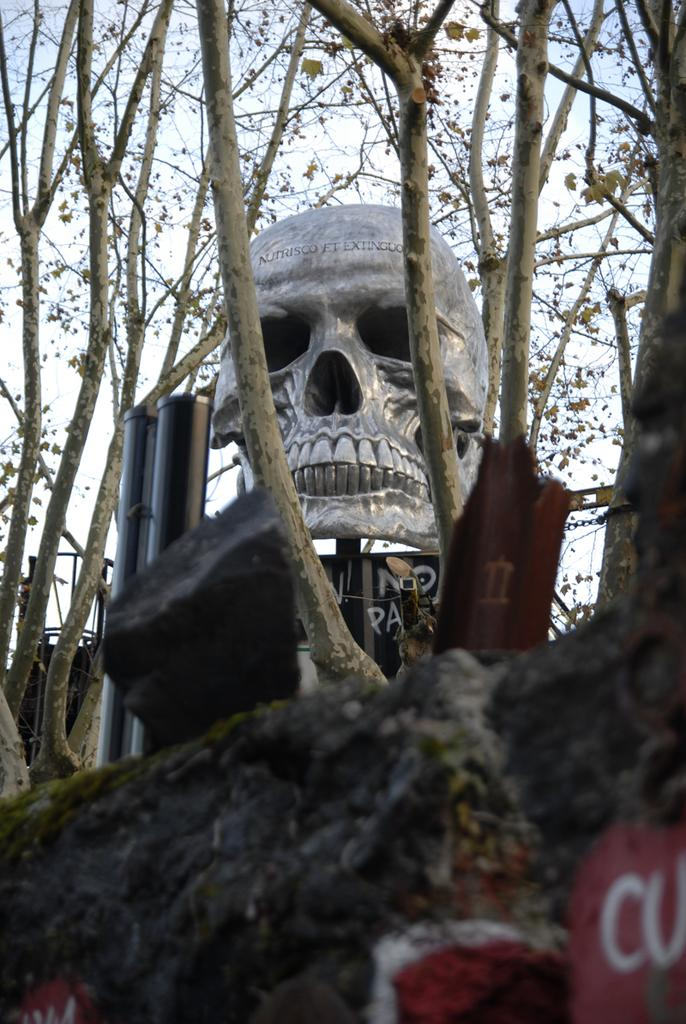What is the main subject of the image? The main subject of the image is a structure of a skull. What is the skull placed on? The skull is placed on wood. What color can be seen on the wall in the image? There is red color on the wall in the image. How many bikes are parked next to the skull in the image? There are no bikes present in the image; the main subject is the skull placed on wood. 